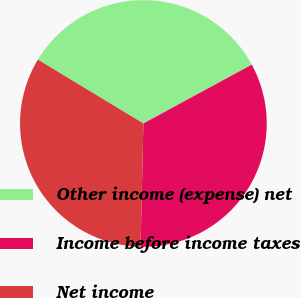<chart> <loc_0><loc_0><loc_500><loc_500><pie_chart><fcel>Other income (expense) net<fcel>Income before income taxes<fcel>Net income<nl><fcel>33.43%<fcel>33.28%<fcel>33.29%<nl></chart> 